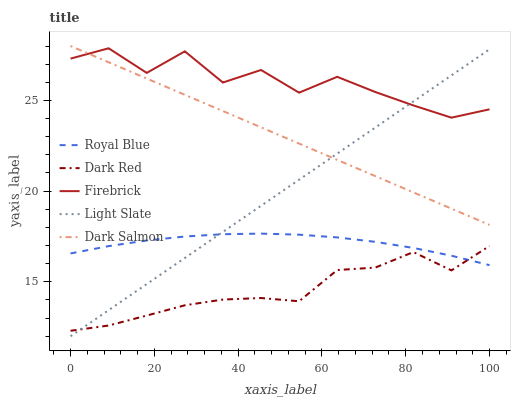Does Dark Red have the minimum area under the curve?
Answer yes or no. Yes. Does Firebrick have the maximum area under the curve?
Answer yes or no. Yes. Does Royal Blue have the minimum area under the curve?
Answer yes or no. No. Does Royal Blue have the maximum area under the curve?
Answer yes or no. No. Is Light Slate the smoothest?
Answer yes or no. Yes. Is Firebrick the roughest?
Answer yes or no. Yes. Is Royal Blue the smoothest?
Answer yes or no. No. Is Royal Blue the roughest?
Answer yes or no. No. Does Royal Blue have the lowest value?
Answer yes or no. No. Does Dark Salmon have the highest value?
Answer yes or no. Yes. Does Royal Blue have the highest value?
Answer yes or no. No. Is Dark Red less than Dark Salmon?
Answer yes or no. Yes. Is Firebrick greater than Dark Red?
Answer yes or no. Yes. Does Dark Red intersect Royal Blue?
Answer yes or no. Yes. Is Dark Red less than Royal Blue?
Answer yes or no. No. Is Dark Red greater than Royal Blue?
Answer yes or no. No. Does Dark Red intersect Dark Salmon?
Answer yes or no. No. 